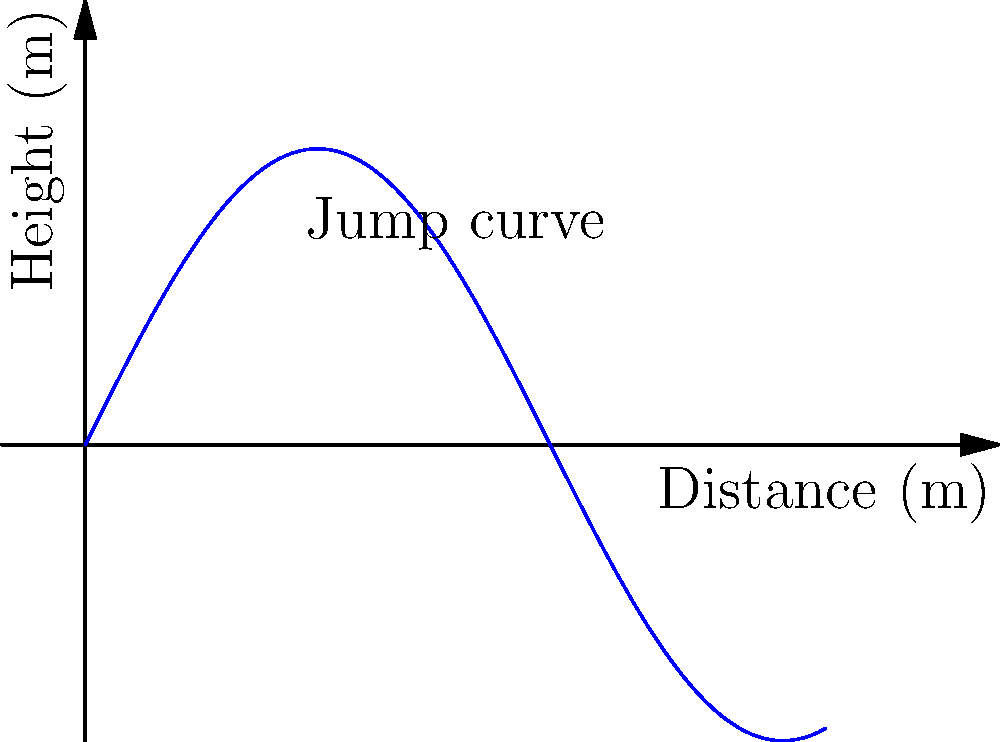In a thrilling long jump competition, an athlete's performance curve is modeled by the function $h(x) = 4\sin(\frac{x}{2})$, where $h$ represents the height in meters and $x$ represents the horizontal distance in meters. If the jump extends from $x=0$ to $x=10$ meters, calculate the total area under the curve to determine the impressive distance covered by the athlete. Round your answer to two decimal places. To find the area under the curve, we need to integrate the function $h(x) = 4\sin(\frac{x}{2})$ from $x=0$ to $x=10$.

Step 1: Set up the definite integral
$$A = \int_{0}^{10} 4\sin(\frac{x}{2}) dx$$

Step 2: Use the substitution method
Let $u = \frac{x}{2}$, then $du = \frac{1}{2}dx$ and $dx = 2du$
When $x = 0$, $u = 0$; when $x = 10$, $u = 5$

Rewrite the integral:
$$A = \int_{0}^{5} 4\sin(u) \cdot 2du = 8\int_{0}^{5} \sin(u) du$$

Step 3: Integrate
$$A = 8[-\cos(u)]_{0}^{5}$$

Step 4: Evaluate the integral
$$A = 8[-\cos(5) + \cos(0)]$$
$$A = 8[-\cos(5) + 1]$$

Step 5: Calculate the result
$$A \approx 8(1.7163) \approx 13.7304$$

Step 6: Round to two decimal places
$$A \approx 13.73 \text{ square meters}$$

This area represents the total distance covered by the athlete during the long jump.
Answer: 13.73 square meters 